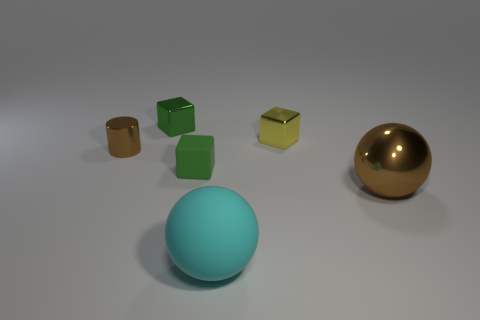The small object in front of the metal thing that is on the left side of the tiny green block that is on the left side of the small matte thing is what color?
Give a very brief answer. Green. What number of objects are both behind the small brown cylinder and in front of the brown metallic sphere?
Make the answer very short. 0. Do the big sphere in front of the brown shiny ball and the tiny metallic block right of the small green shiny thing have the same color?
Offer a very short reply. No. Is there anything else that has the same material as the small brown object?
Give a very brief answer. Yes. The green shiny thing that is the same shape as the tiny yellow metal thing is what size?
Your response must be concise. Small. Are there any tiny metallic cylinders on the left side of the green matte cube?
Make the answer very short. Yes. Is the number of metal cylinders behind the big cyan rubber sphere the same as the number of big yellow rubber things?
Your answer should be very brief. No. There is a green thing that is in front of the small metal block on the left side of the yellow block; are there any green metal cubes that are in front of it?
Provide a succinct answer. No. What material is the brown cylinder?
Make the answer very short. Metal. How many other objects are the same shape as the green metal thing?
Provide a succinct answer. 2. 